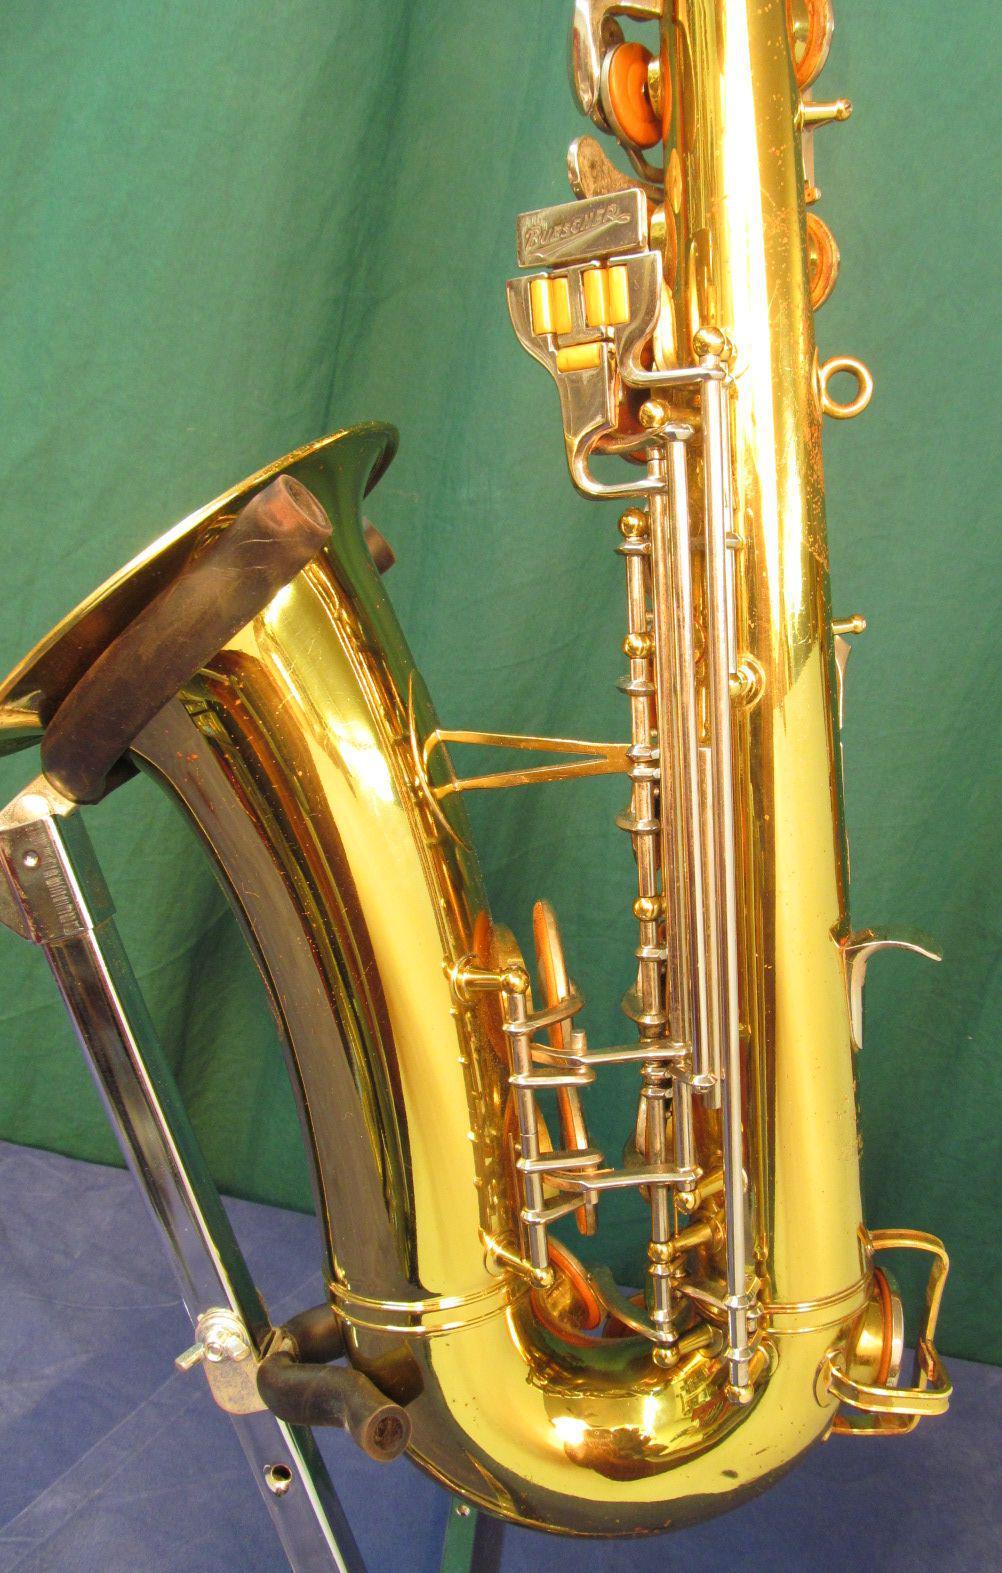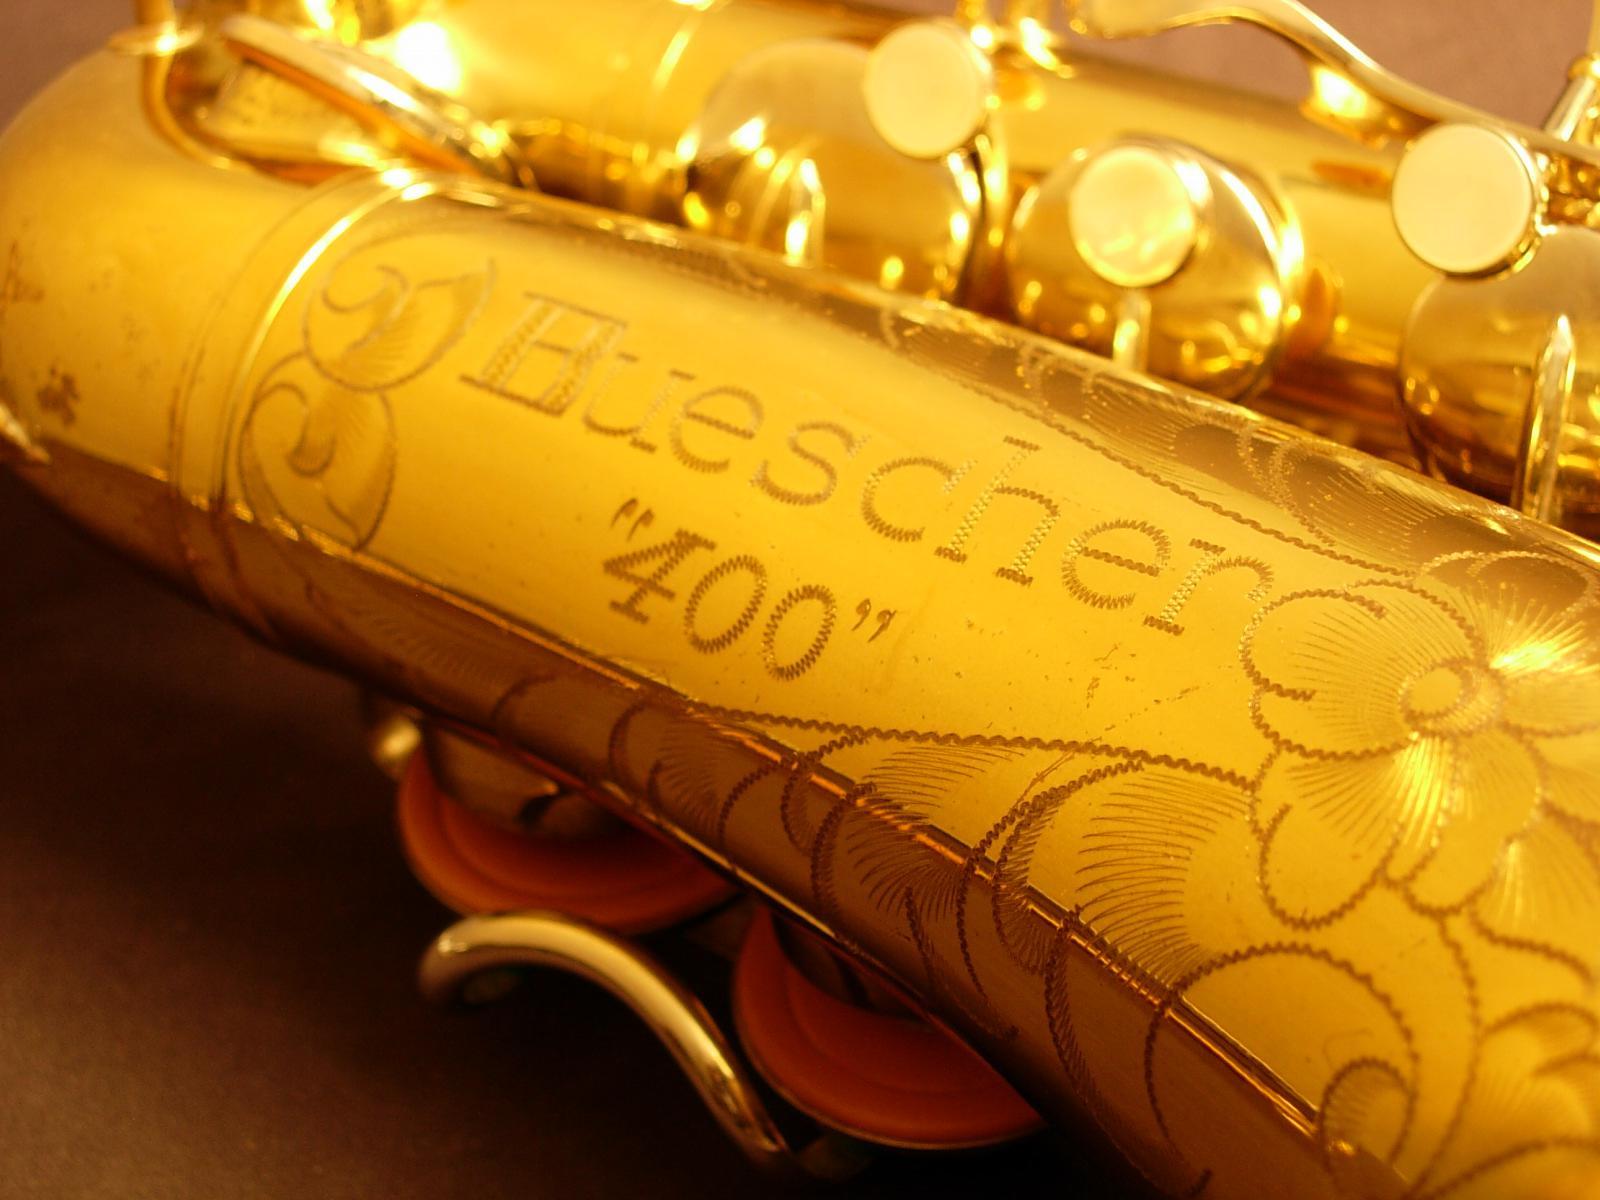The first image is the image on the left, the second image is the image on the right. Given the left and right images, does the statement "A word and number are engraved on the saxophone in the image on the right." hold true? Answer yes or no. Yes. The first image is the image on the left, the second image is the image on the right. Analyze the images presented: Is the assertion "One image shows the gold-colored bell of a saxophone turned leftward, and the other image shows decorative scrolled etching on a gold-colored instrument." valid? Answer yes or no. Yes. 